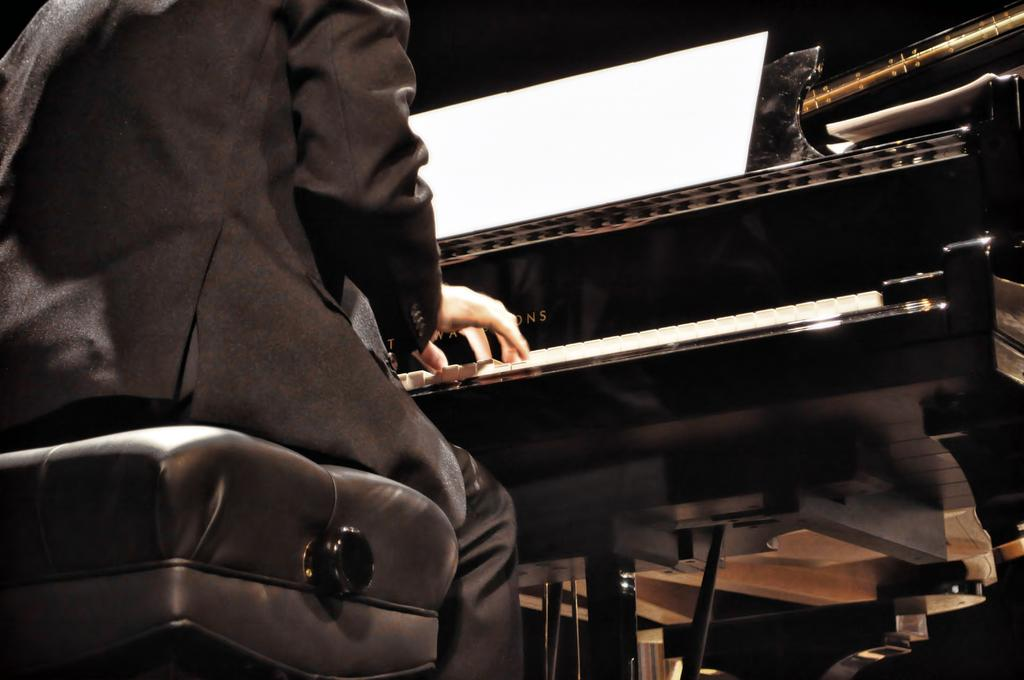Who is present in the image? There is a man in the image. What is the man doing in the image? The man is playing a piano. Where is the man sitting while playing the piano? The man is sitting on a sofa. What type of secretary is visible in the image? There is no secretary present in the image; it features a man playing a piano while sitting on a sofa. 